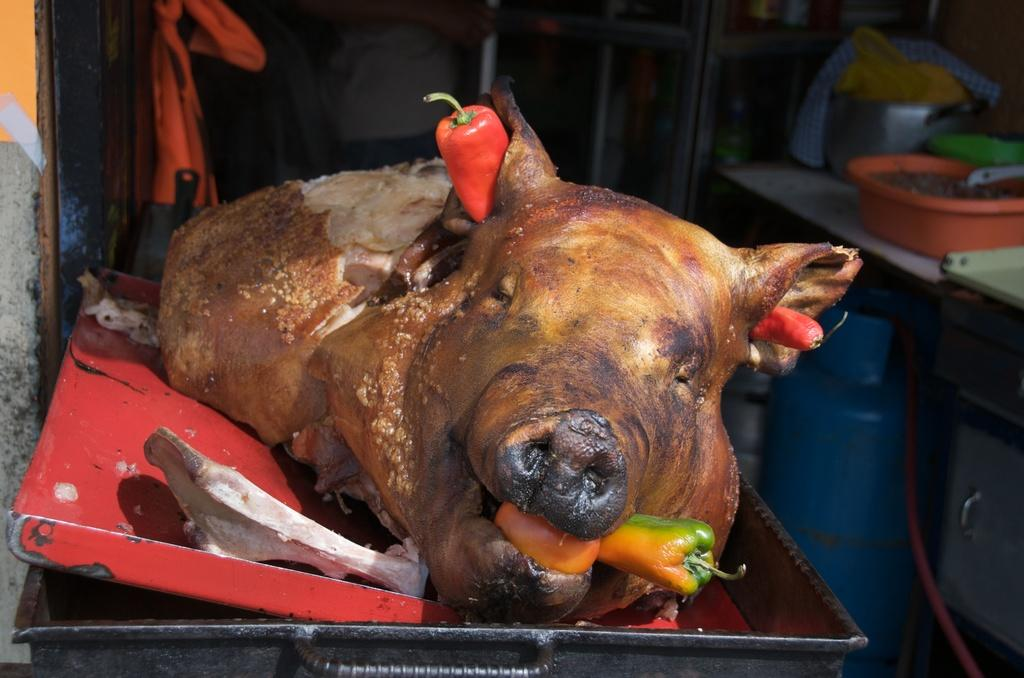What is the main subject of the image? There is a cooked pig in the image. How is the cooked pig presented in the image? The cooked pig is on a tray. What other items are on the tray with the cooked pig? There are red bell peppers and yellow bell peppers on the tray. What type of rock is used to cook the pig in the image? There is no rock present in the image, and the method of cooking the pig is not mentioned. How much rice is served with the cooked pig in the image? There is no rice present in the image. 